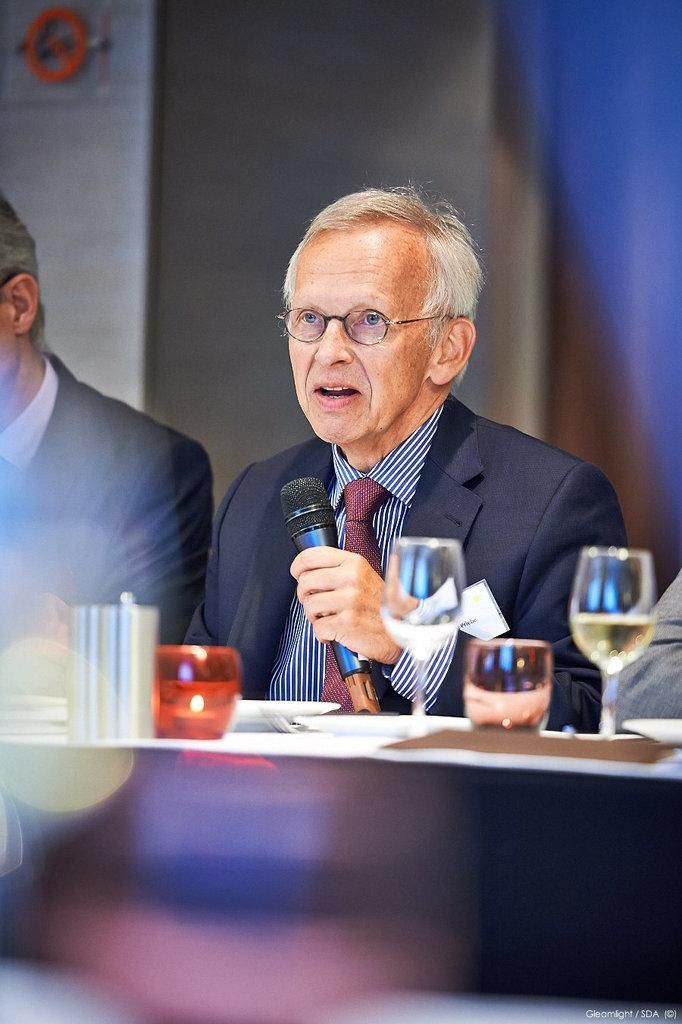What is the man in the image doing? The man is talking on a microphone. What can be seen on the man's face? The man is wearing spectacles. What is the man wearing? The man is wearing a suit. How many people are in the image? There are two people in the image. What is present on the table in the image? There are glasses on the table. What is the purpose of the microphone in the image? The microphone is likely being used for amplifying the man's voice during his speech or presentation. What type of sheep can be seen in the image? There are no sheep present in the image. How does the man express his hate towards the rail in the image? There is no indication of hate or a rail in the image; the man is talking on a microphone and wearing a suit. 